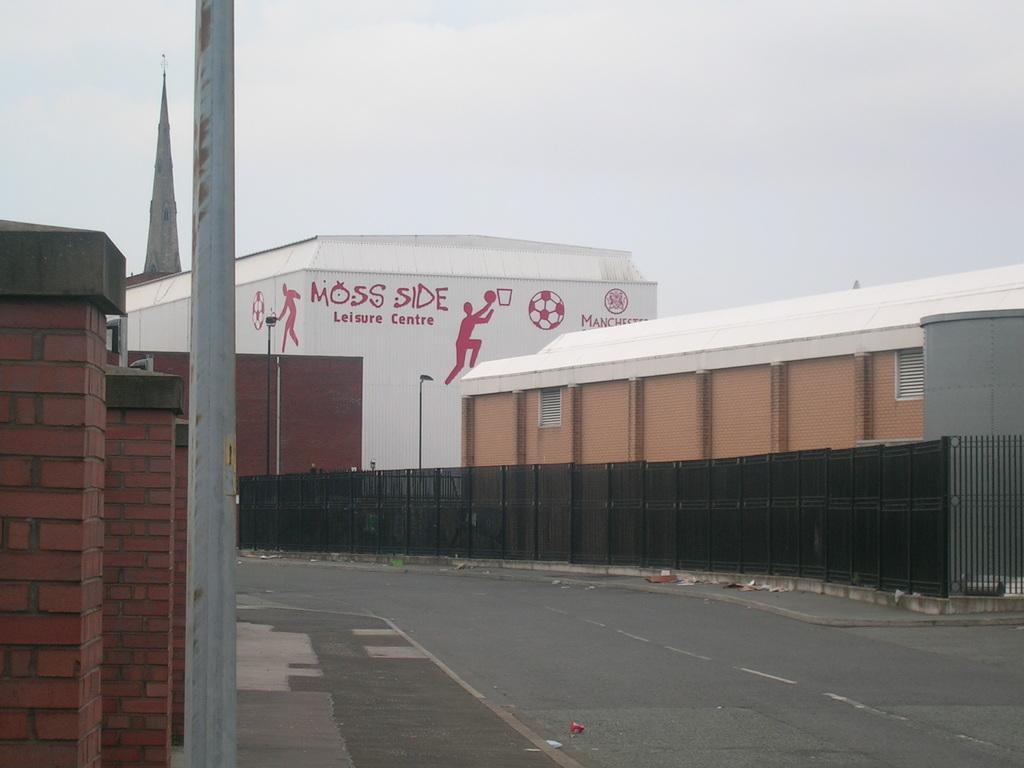Describe this image in one or two sentences. In this picture we can see the road, beside the road there are some buildings. 